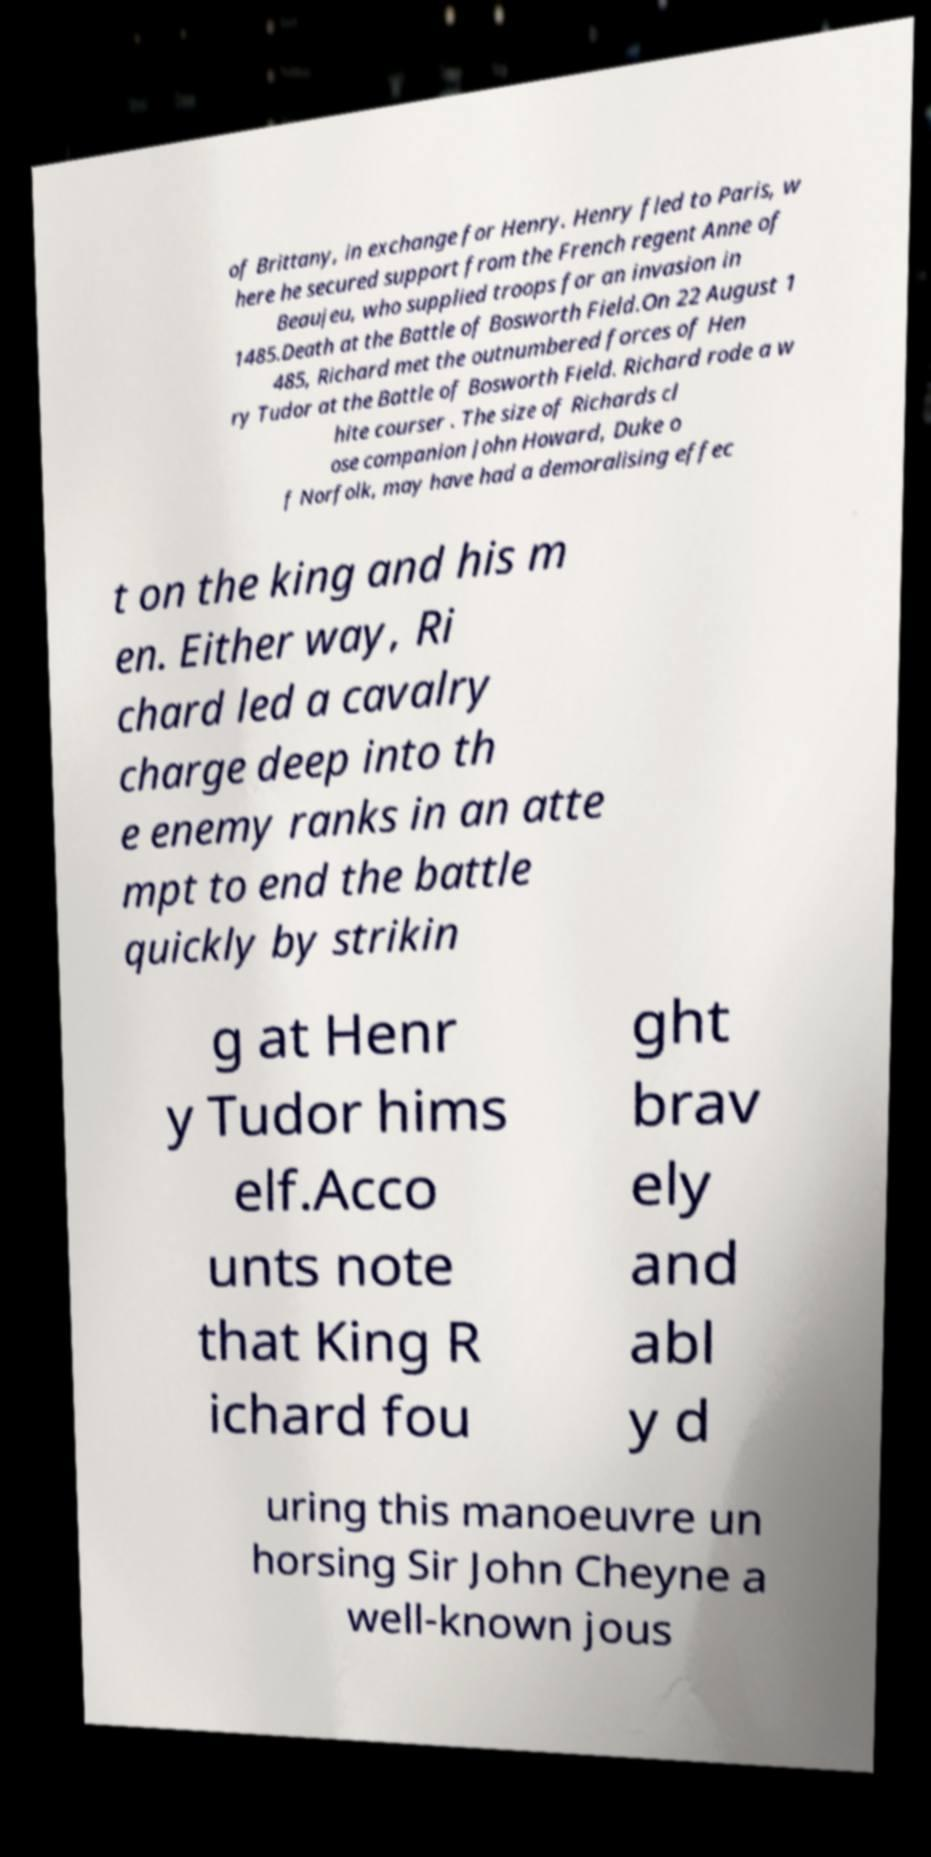There's text embedded in this image that I need extracted. Can you transcribe it verbatim? of Brittany, in exchange for Henry. Henry fled to Paris, w here he secured support from the French regent Anne of Beaujeu, who supplied troops for an invasion in 1485.Death at the Battle of Bosworth Field.On 22 August 1 485, Richard met the outnumbered forces of Hen ry Tudor at the Battle of Bosworth Field. Richard rode a w hite courser . The size of Richards cl ose companion John Howard, Duke o f Norfolk, may have had a demoralising effec t on the king and his m en. Either way, Ri chard led a cavalry charge deep into th e enemy ranks in an atte mpt to end the battle quickly by strikin g at Henr y Tudor hims elf.Acco unts note that King R ichard fou ght brav ely and abl y d uring this manoeuvre un horsing Sir John Cheyne a well-known jous 